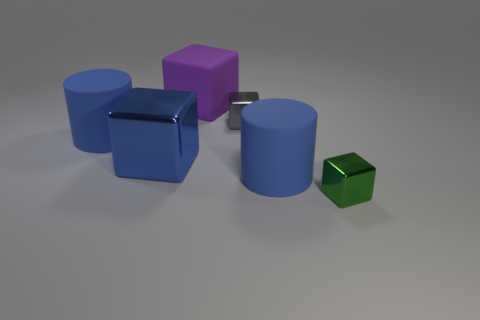How many blocks are gray objects or green things?
Keep it short and to the point. 2. What is the size of the thing behind the small object that is left of the tiny thing that is to the right of the small gray cube?
Your answer should be compact. Large. There is a purple rubber block; are there any green metallic cubes on the left side of it?
Make the answer very short. No. How many objects are matte things that are behind the large blue metal cube or blue matte cylinders?
Your answer should be compact. 3. There is a gray object that is made of the same material as the tiny green object; what is its size?
Your answer should be compact. Small. There is a green metallic block; does it have the same size as the blue matte object that is behind the big metallic block?
Your answer should be very brief. No. There is a shiny cube that is both in front of the small gray thing and left of the green metallic thing; what color is it?
Keep it short and to the point. Blue. How many things are blue matte things that are on the right side of the purple matte thing or blue things to the right of the gray block?
Keep it short and to the point. 1. What color is the tiny block on the right side of the small shiny object that is behind the small metal thing that is in front of the large blue metallic thing?
Provide a short and direct response. Green. Are there any big purple objects that have the same shape as the green thing?
Make the answer very short. Yes. 